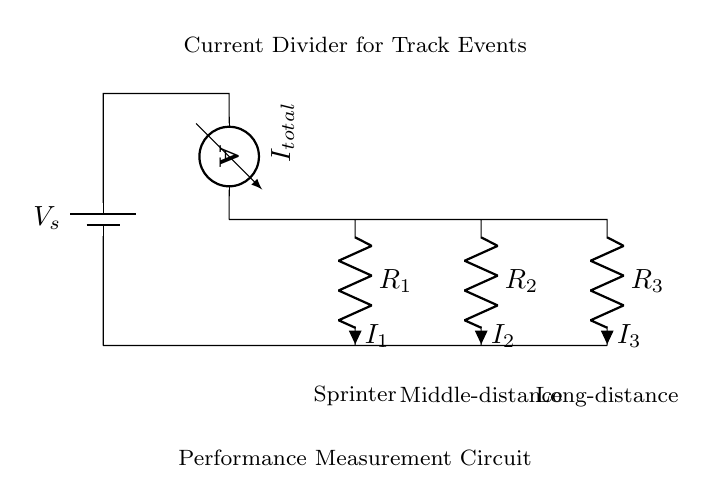What is the total current in the circuit? The total current, denoted as I total, can be identified from the ammeter symbol in the circuit. It measures the total current flowing through the circuit before it divides into the branches.
Answer: I total What are the three resistors labeled in the diagram? The resistors in the diagram are labeled as R1, R2, and R3. Each corresponds to a different athlete's performance measurement: sprinter, middle-distance, and long-distance, respectively.
Answer: R1, R2, R3 Which component is used to measure current in this circuit? The component used to measure the current in this circuit is the ammeter, which is indicated by its symbol in the diagram. It is placed in series to measure the total current flowing through the circuit.
Answer: Ammeter How is the current divided among the resistors? In a current divider circuit, the total current entering the circuit is divided among parallel branches based on the resistance values. The relationship follows the formula I1 = Itotal * (Rtotal/R1), and similar for other resistors, indicating that higher resistance receives less current.
Answer: Based on resistance values What type of circuit is represented in this diagram? The circuit depicted is a current divider, which is specifically designed to split the total current into smaller branches according to the resistances of each branch. This type of configuration allows for performance measurements to be made simultaneously for different track athletes.
Answer: Current divider 